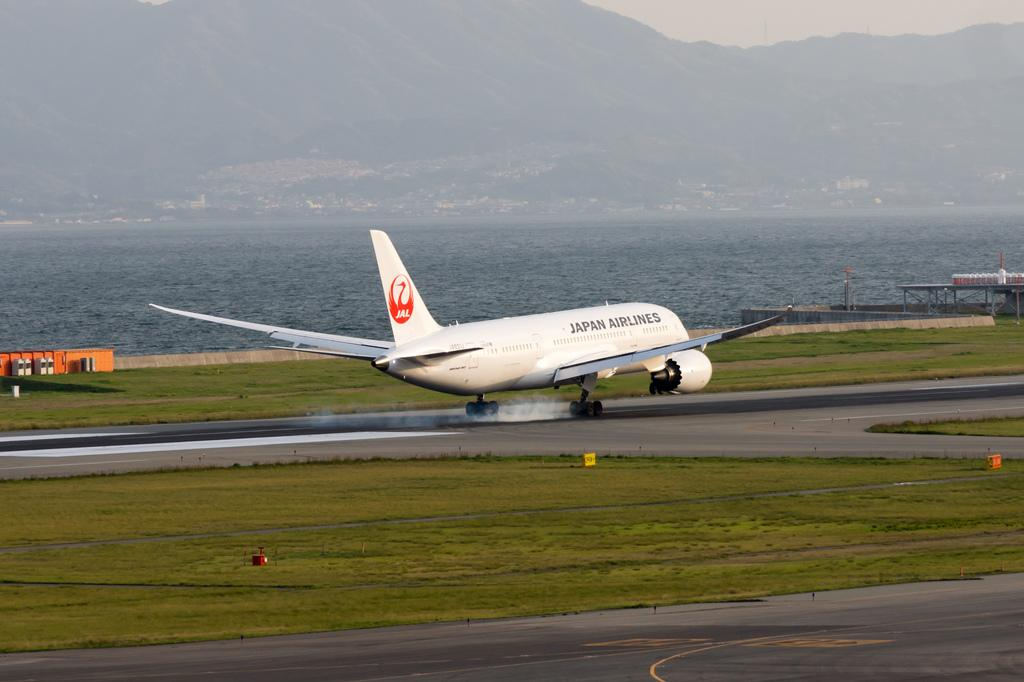<image>
Create a compact narrative representing the image presented. An airplane from Japan Airlines lands on the runway. 